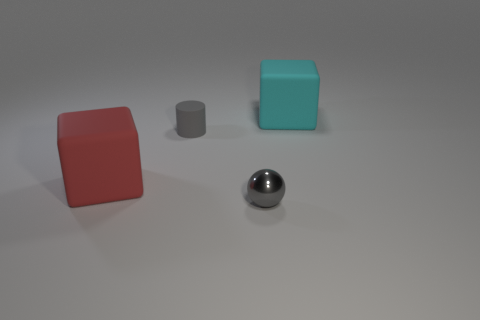Add 1 metal things. How many objects exist? 5 Subtract all cylinders. How many objects are left? 3 Add 4 gray matte things. How many gray matte things exist? 5 Subtract 0 blue cubes. How many objects are left? 4 Subtract all cylinders. Subtract all tiny purple metal balls. How many objects are left? 3 Add 2 tiny gray cylinders. How many tiny gray cylinders are left? 3 